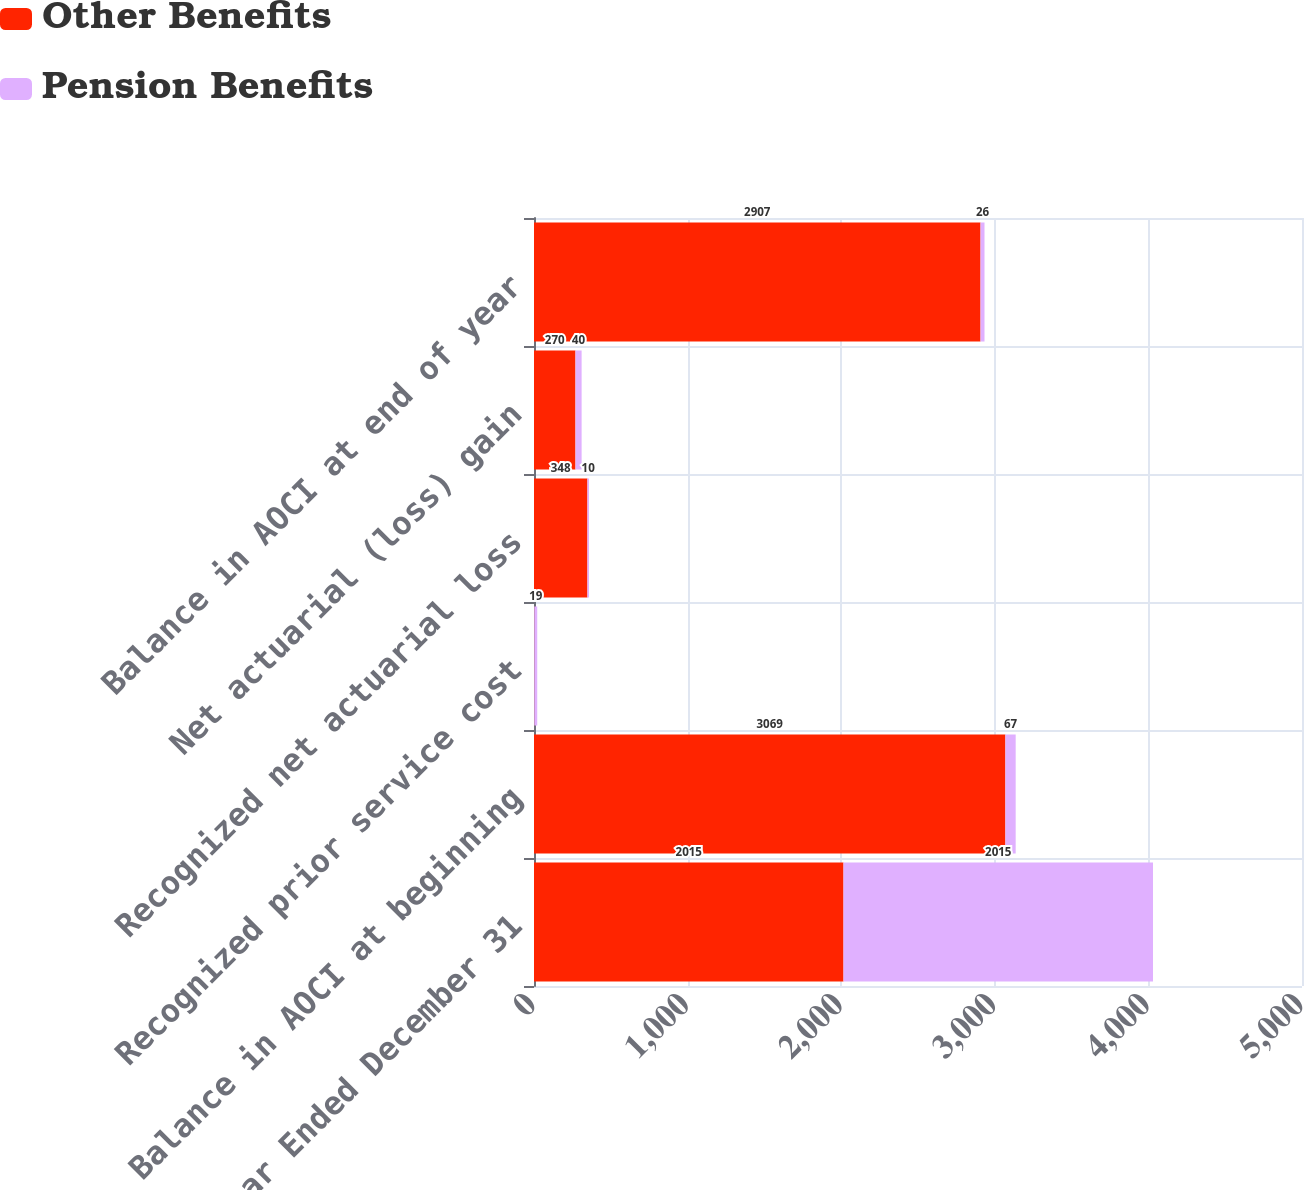Convert chart. <chart><loc_0><loc_0><loc_500><loc_500><stacked_bar_chart><ecel><fcel>Year Ended December 31<fcel>Balance in AOCI at beginning<fcel>Recognized prior service cost<fcel>Recognized net actuarial loss<fcel>Net actuarial (loss) gain<fcel>Balance in AOCI at end of year<nl><fcel>Other Benefits<fcel>2015<fcel>3069<fcel>2<fcel>348<fcel>270<fcel>2907<nl><fcel>Pension Benefits<fcel>2015<fcel>67<fcel>19<fcel>10<fcel>40<fcel>26<nl></chart> 